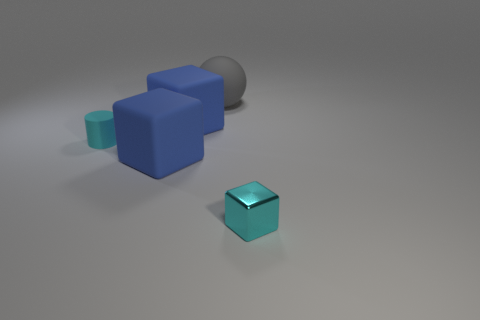Are there any small shiny things that have the same color as the tiny rubber object?
Make the answer very short. Yes. What is the shape of the object that is both in front of the cylinder and behind the tiny cyan shiny cube?
Offer a terse response. Cube. Does the cyan shiny object have the same size as the cyan rubber thing?
Keep it short and to the point. Yes. There is a tiny cyan metal object; how many tiny rubber cylinders are left of it?
Your response must be concise. 1. Are there the same number of large balls to the left of the metallic cube and small cyan cylinders that are on the left side of the sphere?
Offer a terse response. Yes. Is the shape of the big blue rubber thing that is in front of the rubber cylinder the same as  the small cyan metallic object?
Provide a short and direct response. Yes. Is there any other thing that is made of the same material as the small cyan block?
Keep it short and to the point. No. Does the rubber ball have the same size as the blue cube that is behind the tiny cyan matte thing?
Provide a succinct answer. Yes. How many other things are there of the same color as the sphere?
Give a very brief answer. 0. There is a big gray rubber ball; are there any small cyan things right of it?
Give a very brief answer. Yes. 